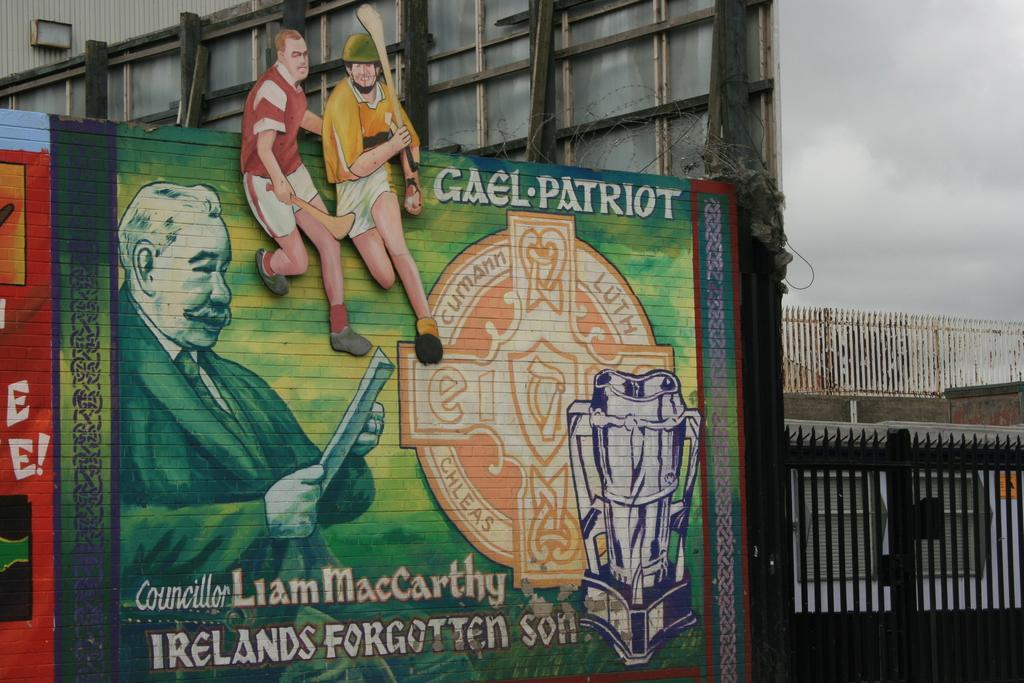<image>
Render a clear and concise summary of the photo. Drawing on a wall showing some cricket players adn the name "Liam Maccarthy". 